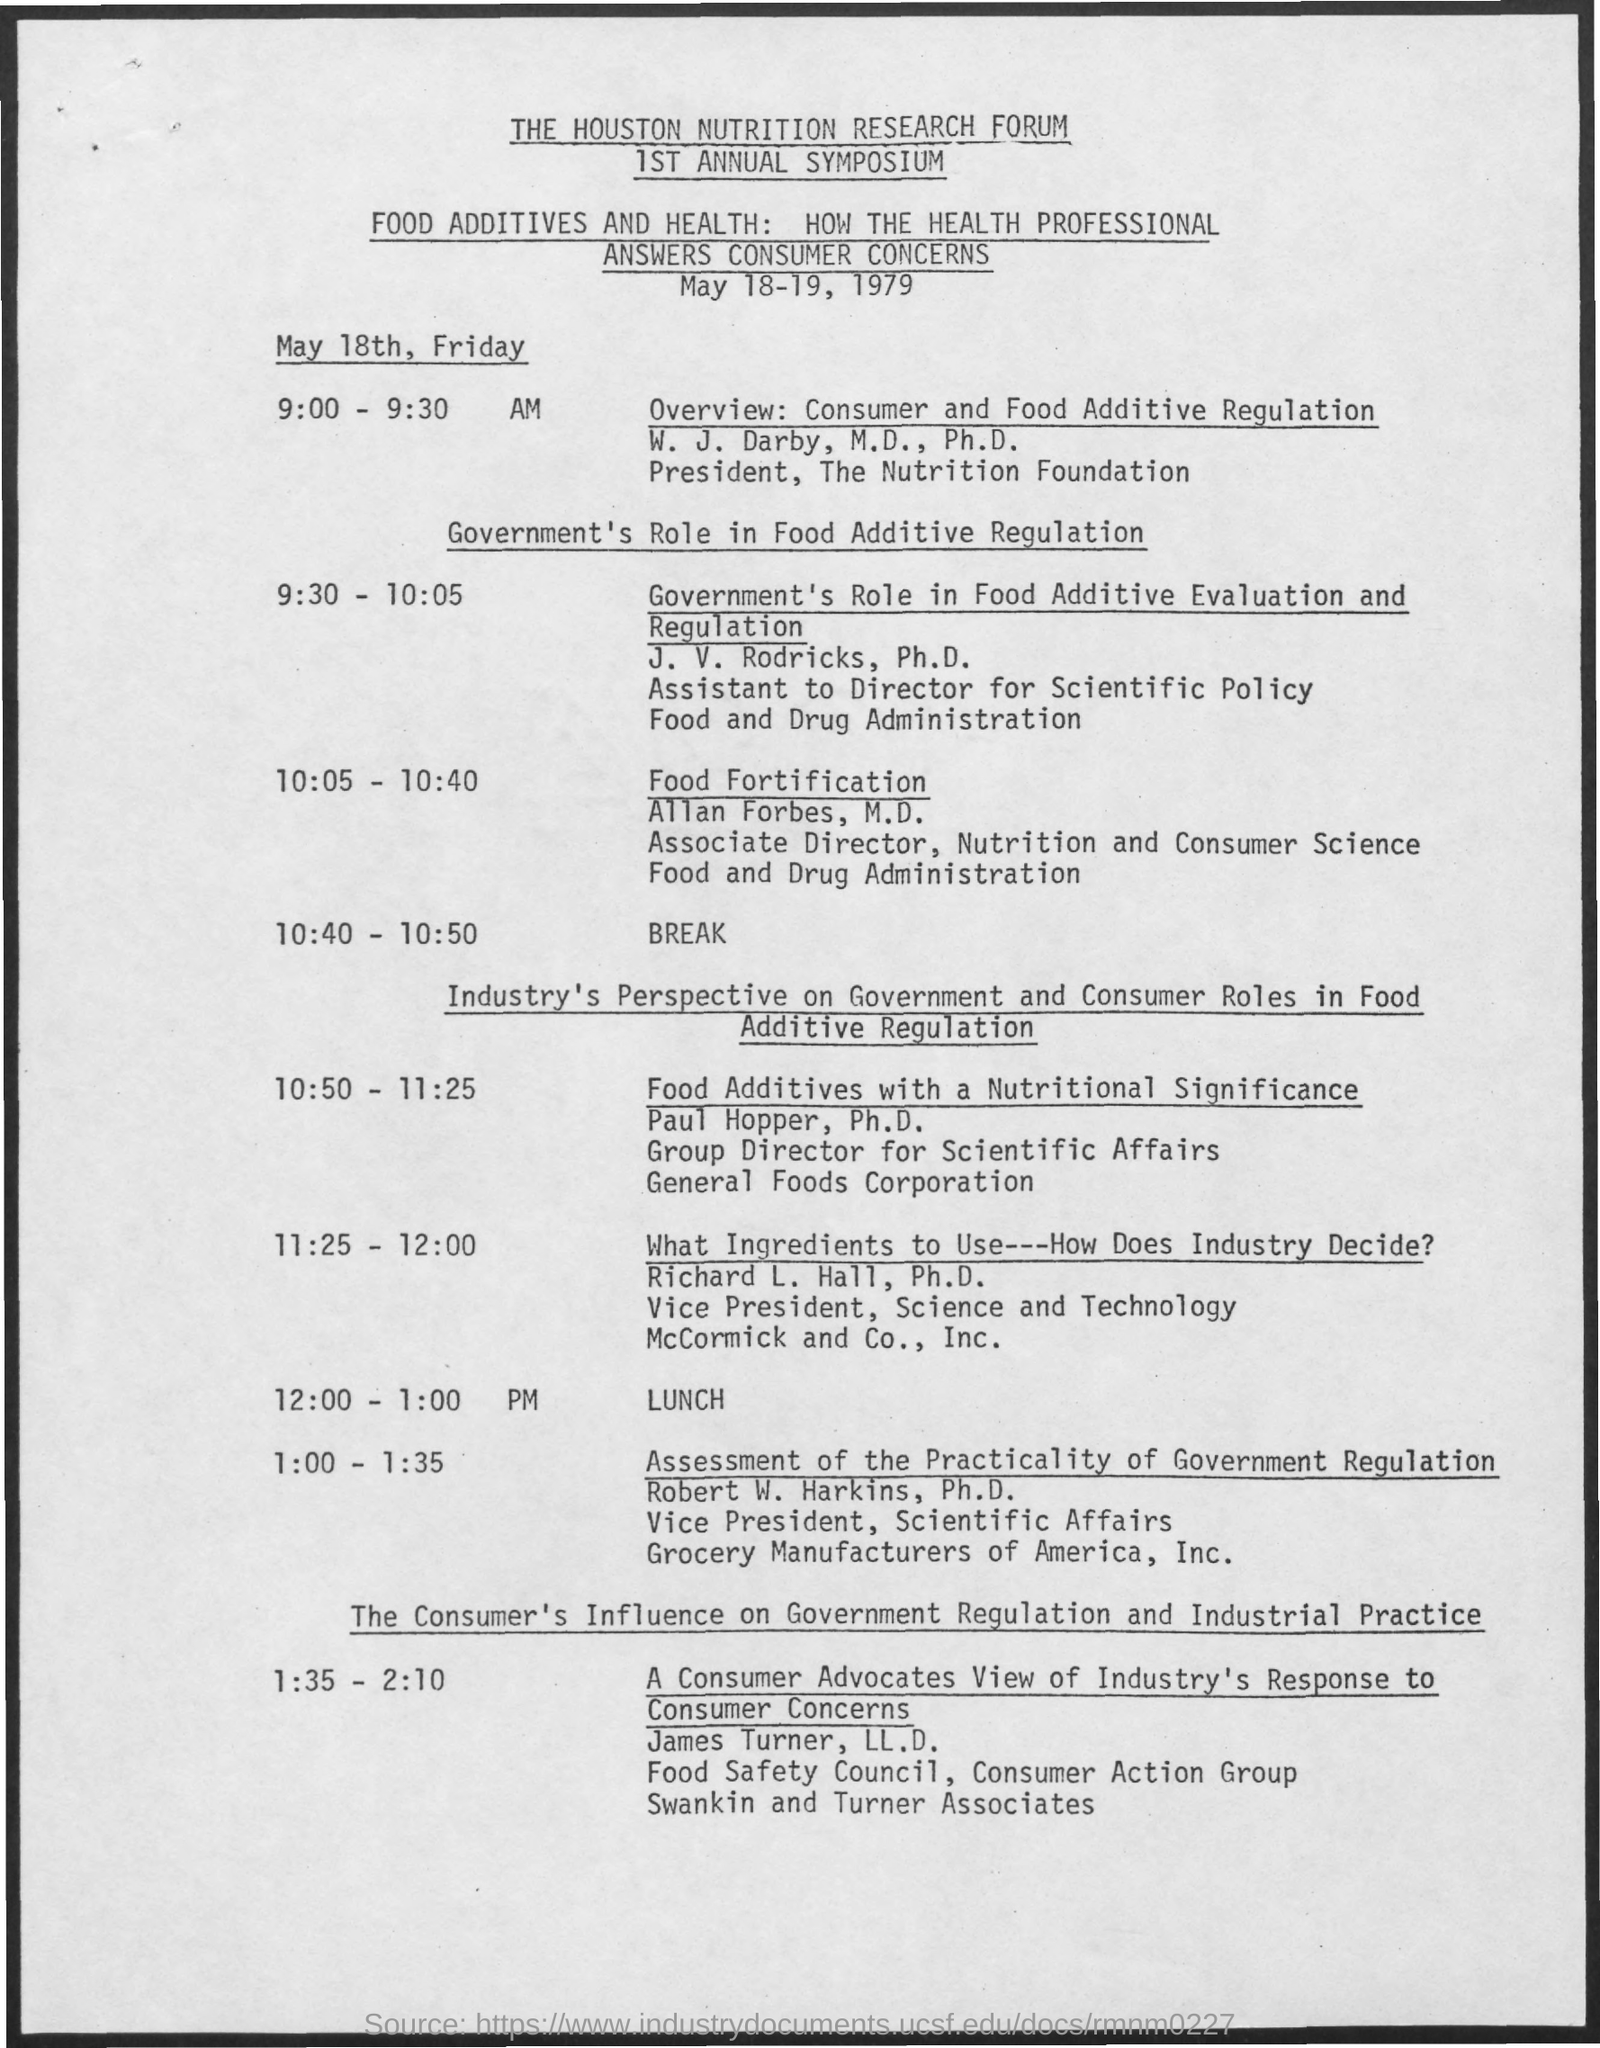What is the date mentioned in the given page ?
Keep it short and to the point. May 18-19, 1979. What is the schedule at the time of 10:40-10:50?
Provide a short and direct response. Break. What is the schedule at the time of 12:00 - 1:00 pm ?
Keep it short and to the point. Lunch. 